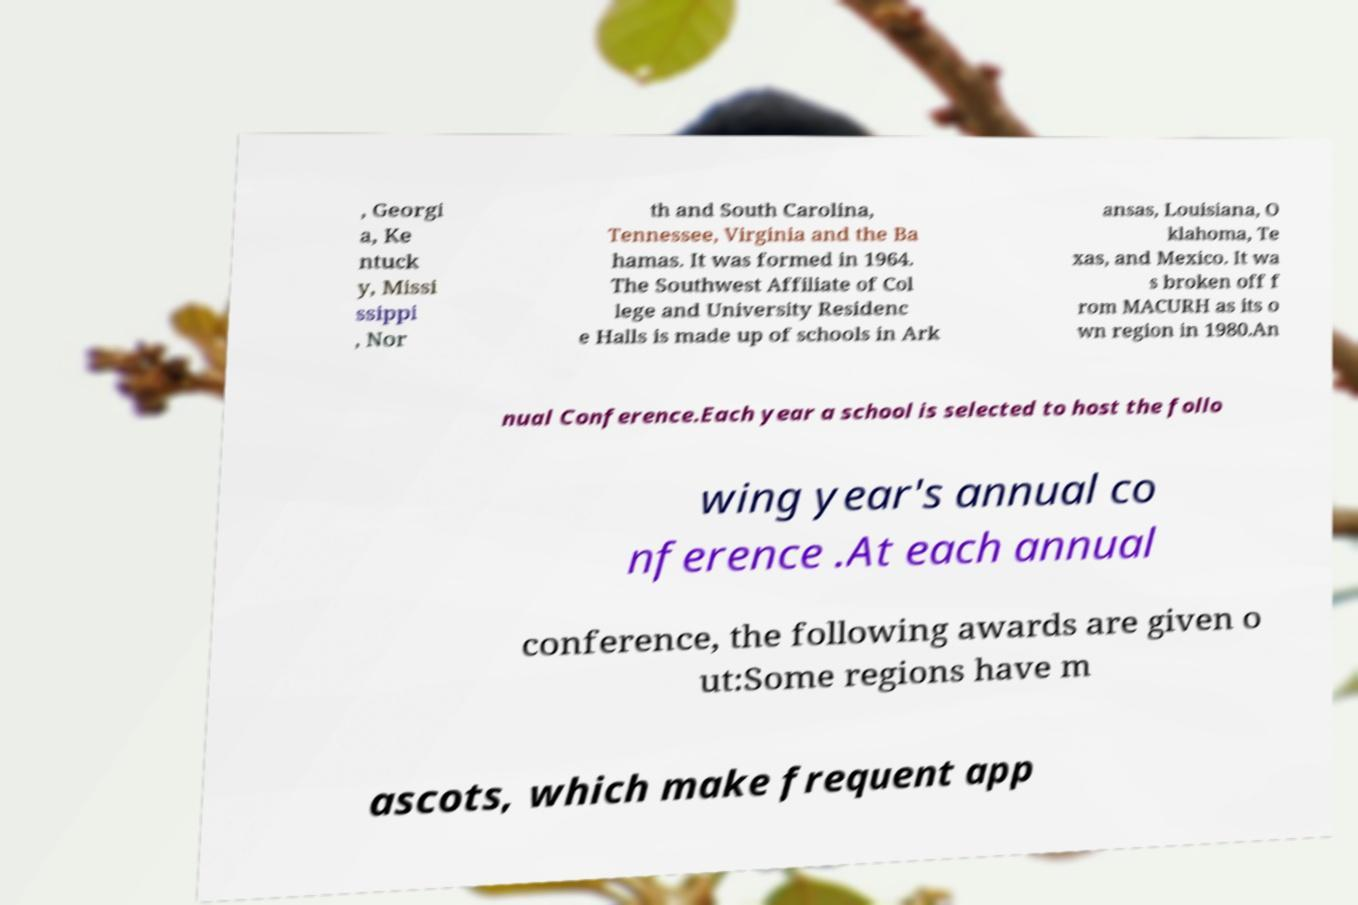Please read and relay the text visible in this image. What does it say? , Georgi a, Ke ntuck y, Missi ssippi , Nor th and South Carolina, Tennessee, Virginia and the Ba hamas. It was formed in 1964. The Southwest Affiliate of Col lege and University Residenc e Halls is made up of schools in Ark ansas, Louisiana, O klahoma, Te xas, and Mexico. It wa s broken off f rom MACURH as its o wn region in 1980.An nual Conference.Each year a school is selected to host the follo wing year's annual co nference .At each annual conference, the following awards are given o ut:Some regions have m ascots, which make frequent app 